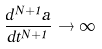<formula> <loc_0><loc_0><loc_500><loc_500>\frac { d ^ { N + 1 } a } { d t ^ { N + 1 } } \rightarrow \infty</formula> 